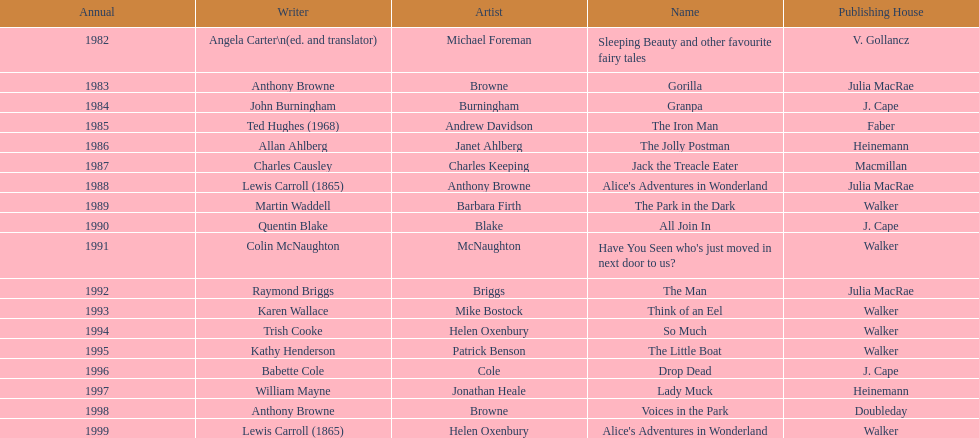What are the number of kurt maschler awards helen oxenbury has won? 2. 